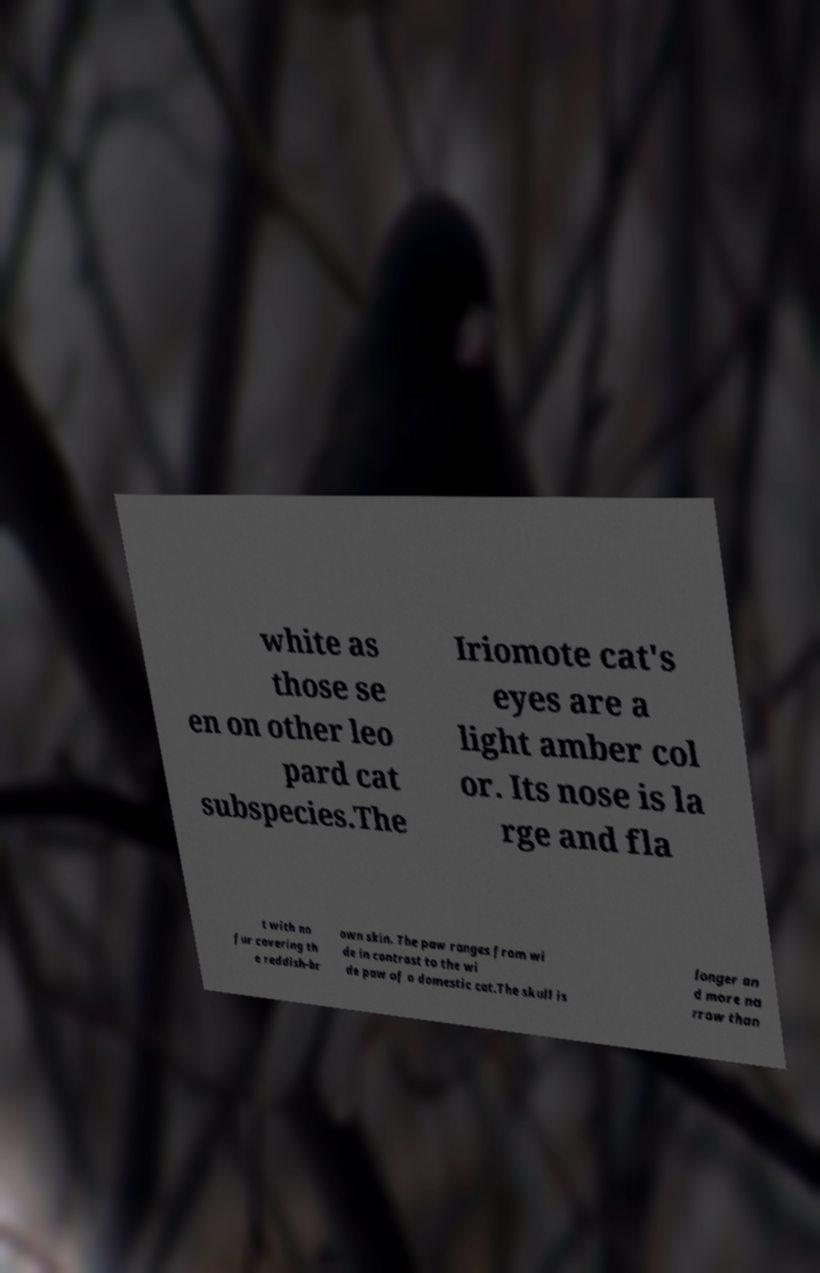Could you assist in decoding the text presented in this image and type it out clearly? white as those se en on other leo pard cat subspecies.The Iriomote cat's eyes are a light amber col or. Its nose is la rge and fla t with no fur covering th e reddish-br own skin. The paw ranges from wi de in contrast to the wi de paw of a domestic cat.The skull is longer an d more na rrow than 